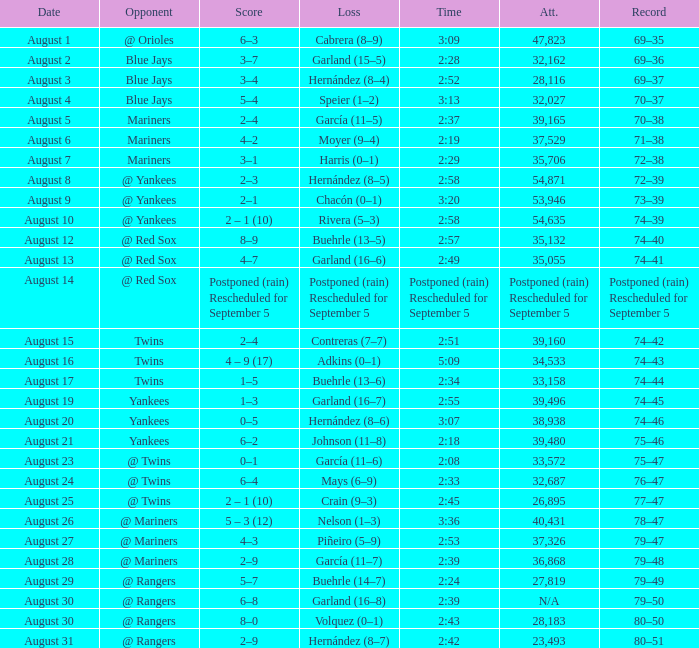Who lost with a time of 2:42? Hernández (8–7). 